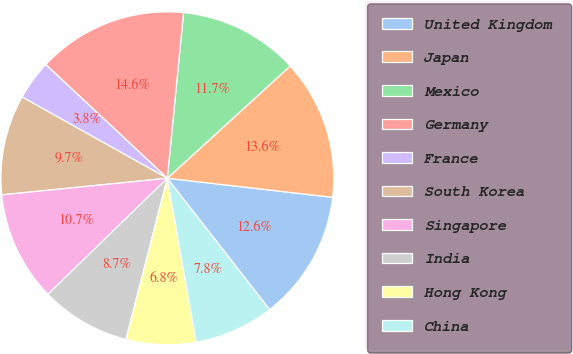Convert chart to OTSL. <chart><loc_0><loc_0><loc_500><loc_500><pie_chart><fcel>United Kingdom<fcel>Japan<fcel>Mexico<fcel>Germany<fcel>France<fcel>South Korea<fcel>Singapore<fcel>India<fcel>Hong Kong<fcel>China<nl><fcel>12.64%<fcel>13.61%<fcel>11.66%<fcel>14.59%<fcel>3.85%<fcel>9.71%<fcel>10.68%<fcel>8.73%<fcel>6.78%<fcel>7.75%<nl></chart> 